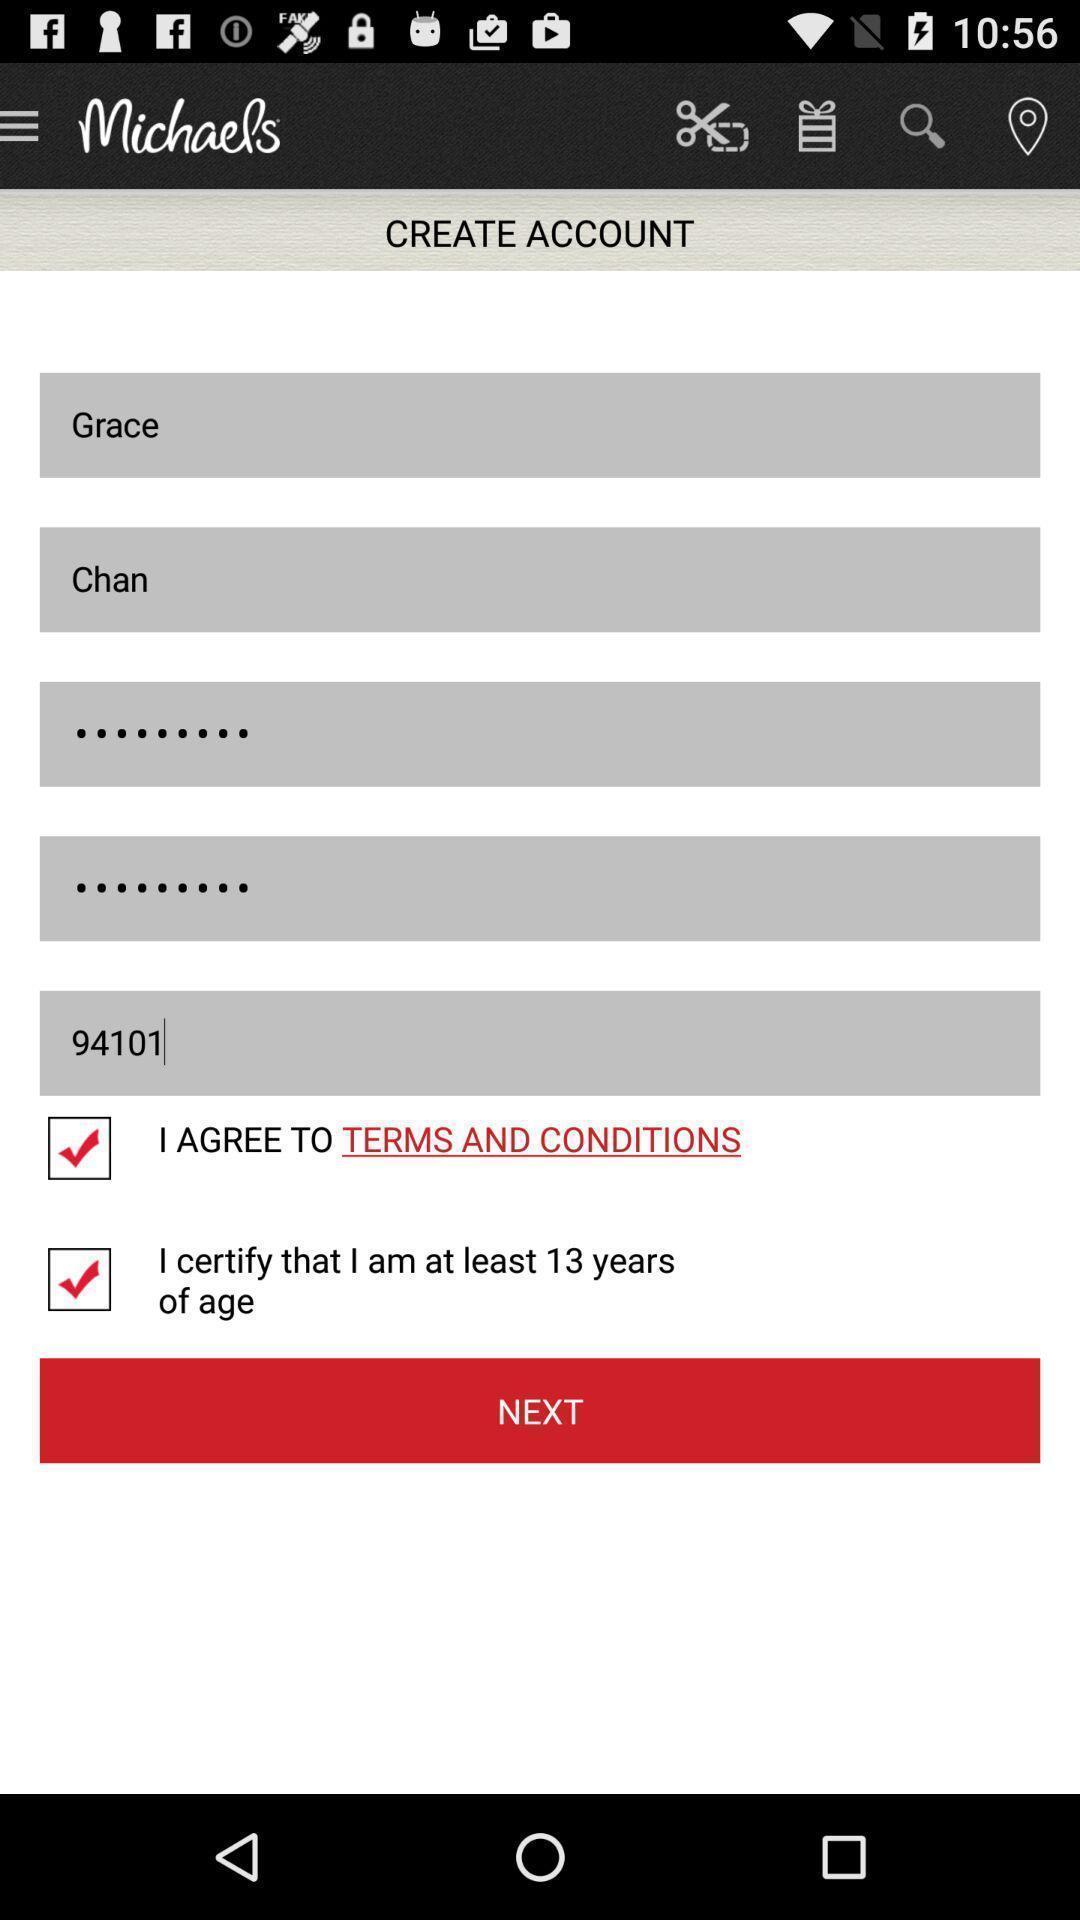Tell me about the visual elements in this screen capture. Sign up page. 